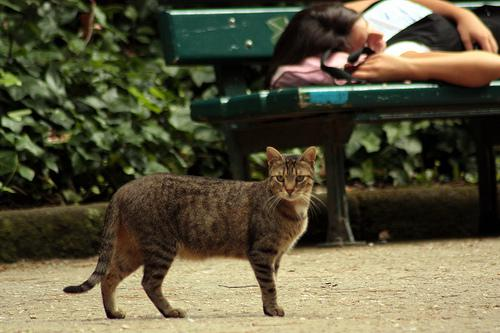Question: what is the woman doing?
Choices:
A. Reading.
B. Sitting.
C. Sleeping.
D. Watching tv.
Answer with the letter. Answer: C Question: where is the woman sleeping?
Choices:
A. A couch.
B. A bench.
C. A chair.
D. A bed.
Answer with the letter. Answer: B 